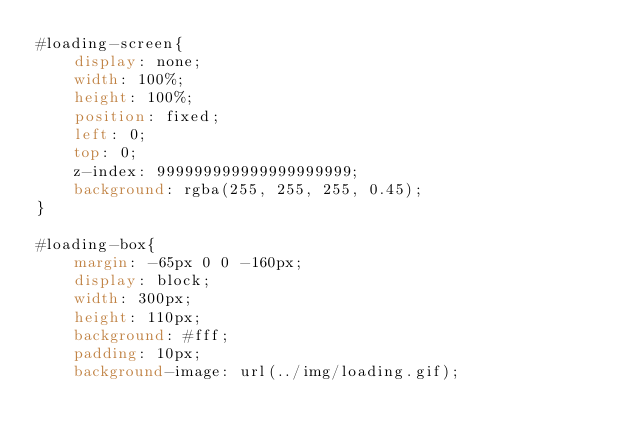<code> <loc_0><loc_0><loc_500><loc_500><_CSS_>#loading-screen{
	display: none;
	width: 100%;
	height: 100%;
	position: fixed;
	left: 0;
	top: 0;
	z-index: 999999999999999999999;
	background: rgba(255, 255, 255, 0.45);
}

#loading-box{
	margin: -65px 0 0 -160px;
	display: block;
	width: 300px;
	height: 110px;
	background: #fff;
	padding: 10px;
	background-image: url(../img/loading.gif);</code> 